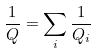Convert formula to latex. <formula><loc_0><loc_0><loc_500><loc_500>\frac { 1 } { Q } = \sum _ { i } \frac { 1 } { Q _ { i } }</formula> 